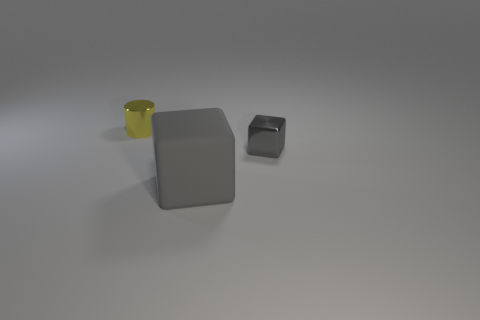How big is the gray object to the left of the tiny object to the right of the thing behind the tiny gray block?
Your response must be concise. Large. What is the material of the yellow thing?
Provide a short and direct response. Metal. There is a thing that is the same color as the tiny shiny cube; what size is it?
Your answer should be very brief. Large. There is a rubber object; is its shape the same as the tiny thing that is in front of the cylinder?
Offer a terse response. Yes. What material is the cube to the left of the gray cube behind the gray cube in front of the tiny gray shiny cube?
Offer a very short reply. Rubber. How many small gray matte cylinders are there?
Provide a short and direct response. 0. How many yellow things are matte objects or small objects?
Keep it short and to the point. 1. How many other objects are the same shape as the matte object?
Make the answer very short. 1. There is a metal object that is behind the gray metal object; is its color the same as the cube in front of the tiny cube?
Give a very brief answer. No. What number of small things are cylinders or purple rubber things?
Offer a terse response. 1. 